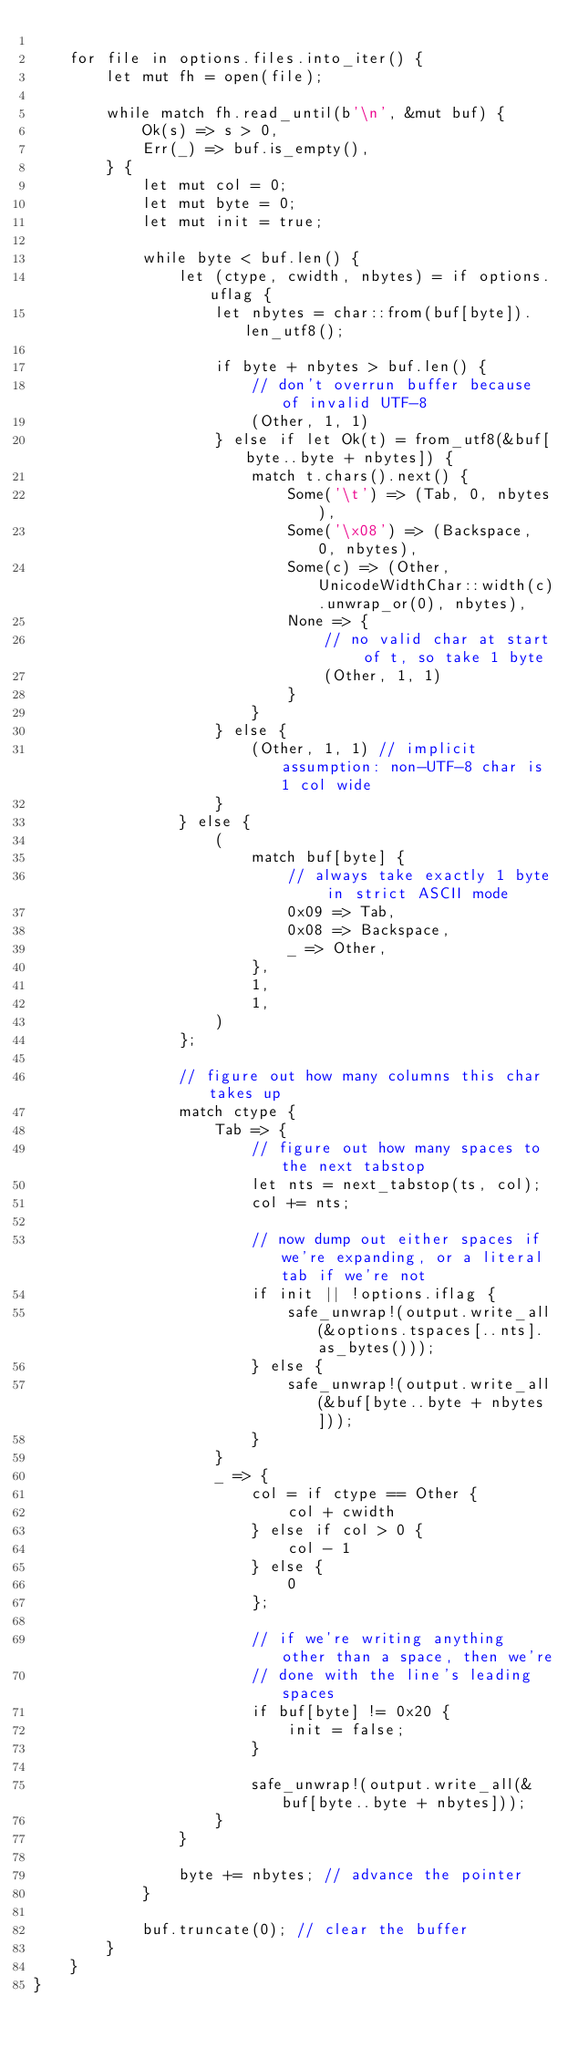<code> <loc_0><loc_0><loc_500><loc_500><_Rust_>
    for file in options.files.into_iter() {
        let mut fh = open(file);

        while match fh.read_until(b'\n', &mut buf) {
            Ok(s) => s > 0,
            Err(_) => buf.is_empty(),
        } {
            let mut col = 0;
            let mut byte = 0;
            let mut init = true;

            while byte < buf.len() {
                let (ctype, cwidth, nbytes) = if options.uflag {
                    let nbytes = char::from(buf[byte]).len_utf8();

                    if byte + nbytes > buf.len() {
                        // don't overrun buffer because of invalid UTF-8
                        (Other, 1, 1)
                    } else if let Ok(t) = from_utf8(&buf[byte..byte + nbytes]) {
                        match t.chars().next() {
                            Some('\t') => (Tab, 0, nbytes),
                            Some('\x08') => (Backspace, 0, nbytes),
                            Some(c) => (Other, UnicodeWidthChar::width(c).unwrap_or(0), nbytes),
                            None => {
                                // no valid char at start of t, so take 1 byte
                                (Other, 1, 1)
                            }
                        }
                    } else {
                        (Other, 1, 1) // implicit assumption: non-UTF-8 char is 1 col wide
                    }
                } else {
                    (
                        match buf[byte] {
                            // always take exactly 1 byte in strict ASCII mode
                            0x09 => Tab,
                            0x08 => Backspace,
                            _ => Other,
                        },
                        1,
                        1,
                    )
                };

                // figure out how many columns this char takes up
                match ctype {
                    Tab => {
                        // figure out how many spaces to the next tabstop
                        let nts = next_tabstop(ts, col);
                        col += nts;

                        // now dump out either spaces if we're expanding, or a literal tab if we're not
                        if init || !options.iflag {
                            safe_unwrap!(output.write_all(&options.tspaces[..nts].as_bytes()));
                        } else {
                            safe_unwrap!(output.write_all(&buf[byte..byte + nbytes]));
                        }
                    }
                    _ => {
                        col = if ctype == Other {
                            col + cwidth
                        } else if col > 0 {
                            col - 1
                        } else {
                            0
                        };

                        // if we're writing anything other than a space, then we're
                        // done with the line's leading spaces
                        if buf[byte] != 0x20 {
                            init = false;
                        }

                        safe_unwrap!(output.write_all(&buf[byte..byte + nbytes]));
                    }
                }

                byte += nbytes; // advance the pointer
            }

            buf.truncate(0); // clear the buffer
        }
    }
}
</code> 